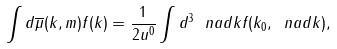Convert formula to latex. <formula><loc_0><loc_0><loc_500><loc_500>\int d \overline { \mu } ( k , m ) f ( k ) = \frac { 1 } { 2 u ^ { 0 } } \int d ^ { 3 } \ n a d { k } f ( k _ { 0 } , \ n a d { k } ) ,</formula> 